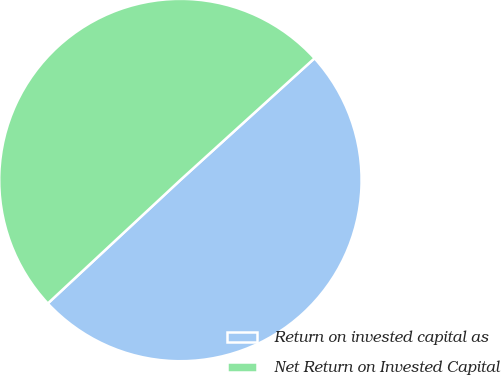Convert chart to OTSL. <chart><loc_0><loc_0><loc_500><loc_500><pie_chart><fcel>Return on invested capital as<fcel>Net Return on Invested Capital<nl><fcel>49.8%<fcel>50.2%<nl></chart> 